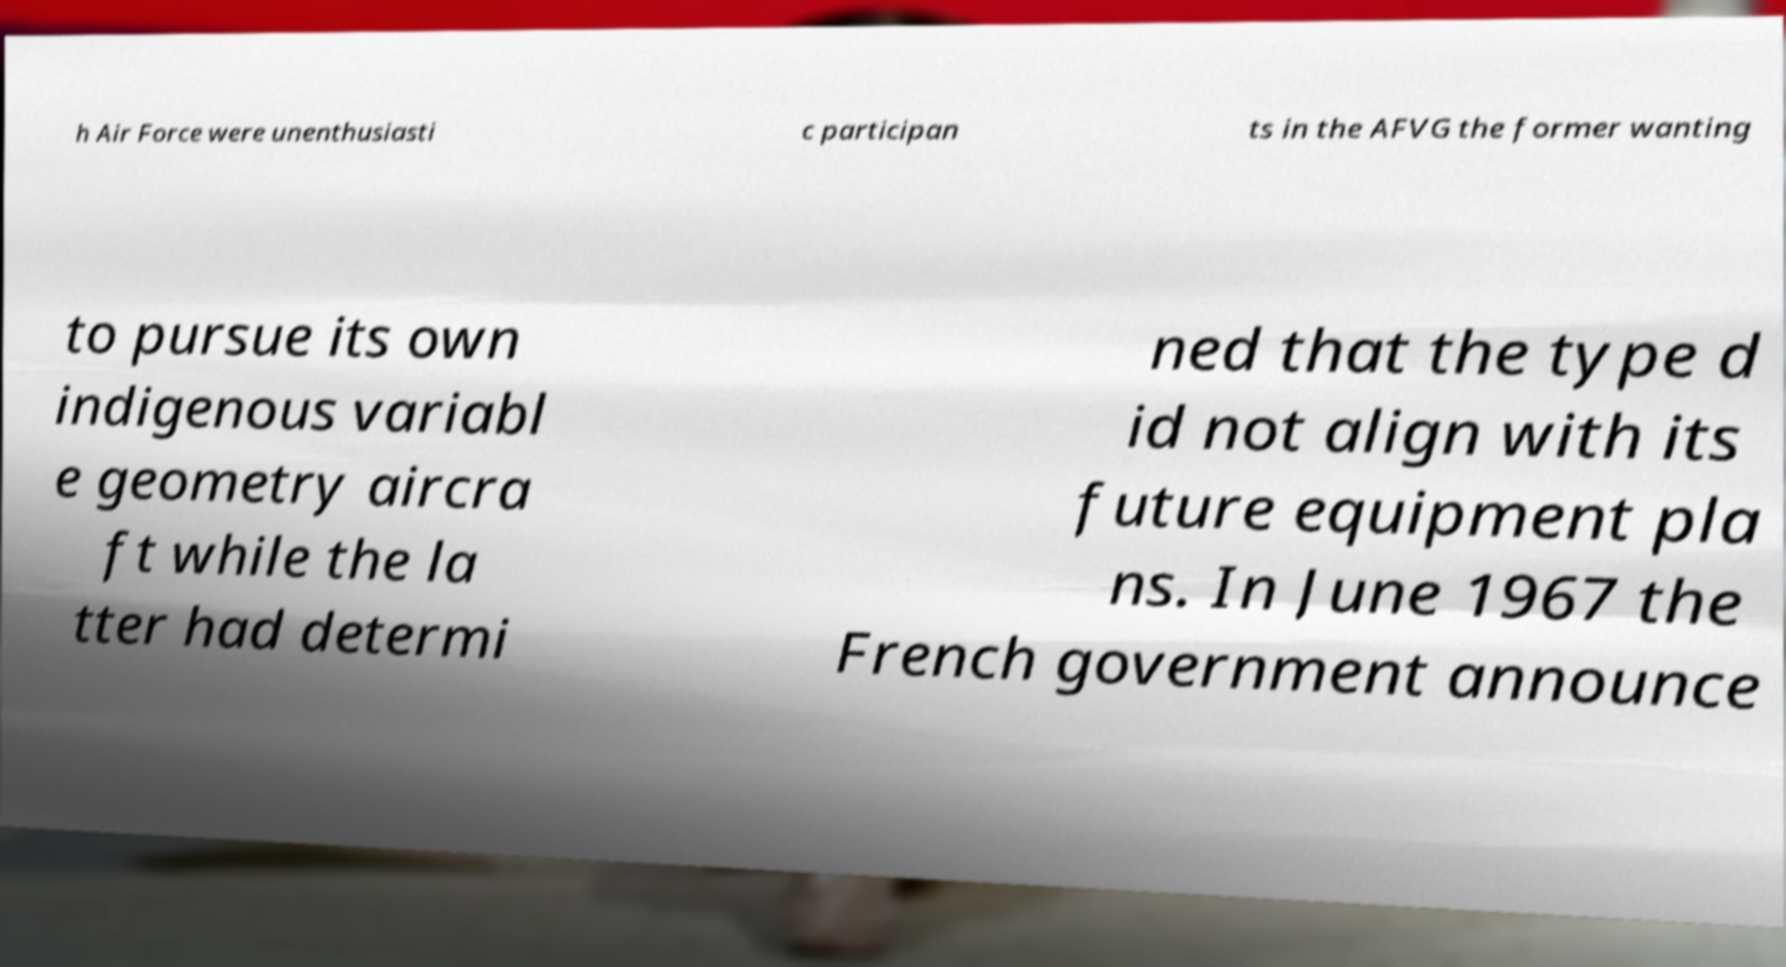Please read and relay the text visible in this image. What does it say? h Air Force were unenthusiasti c participan ts in the AFVG the former wanting to pursue its own indigenous variabl e geometry aircra ft while the la tter had determi ned that the type d id not align with its future equipment pla ns. In June 1967 the French government announce 